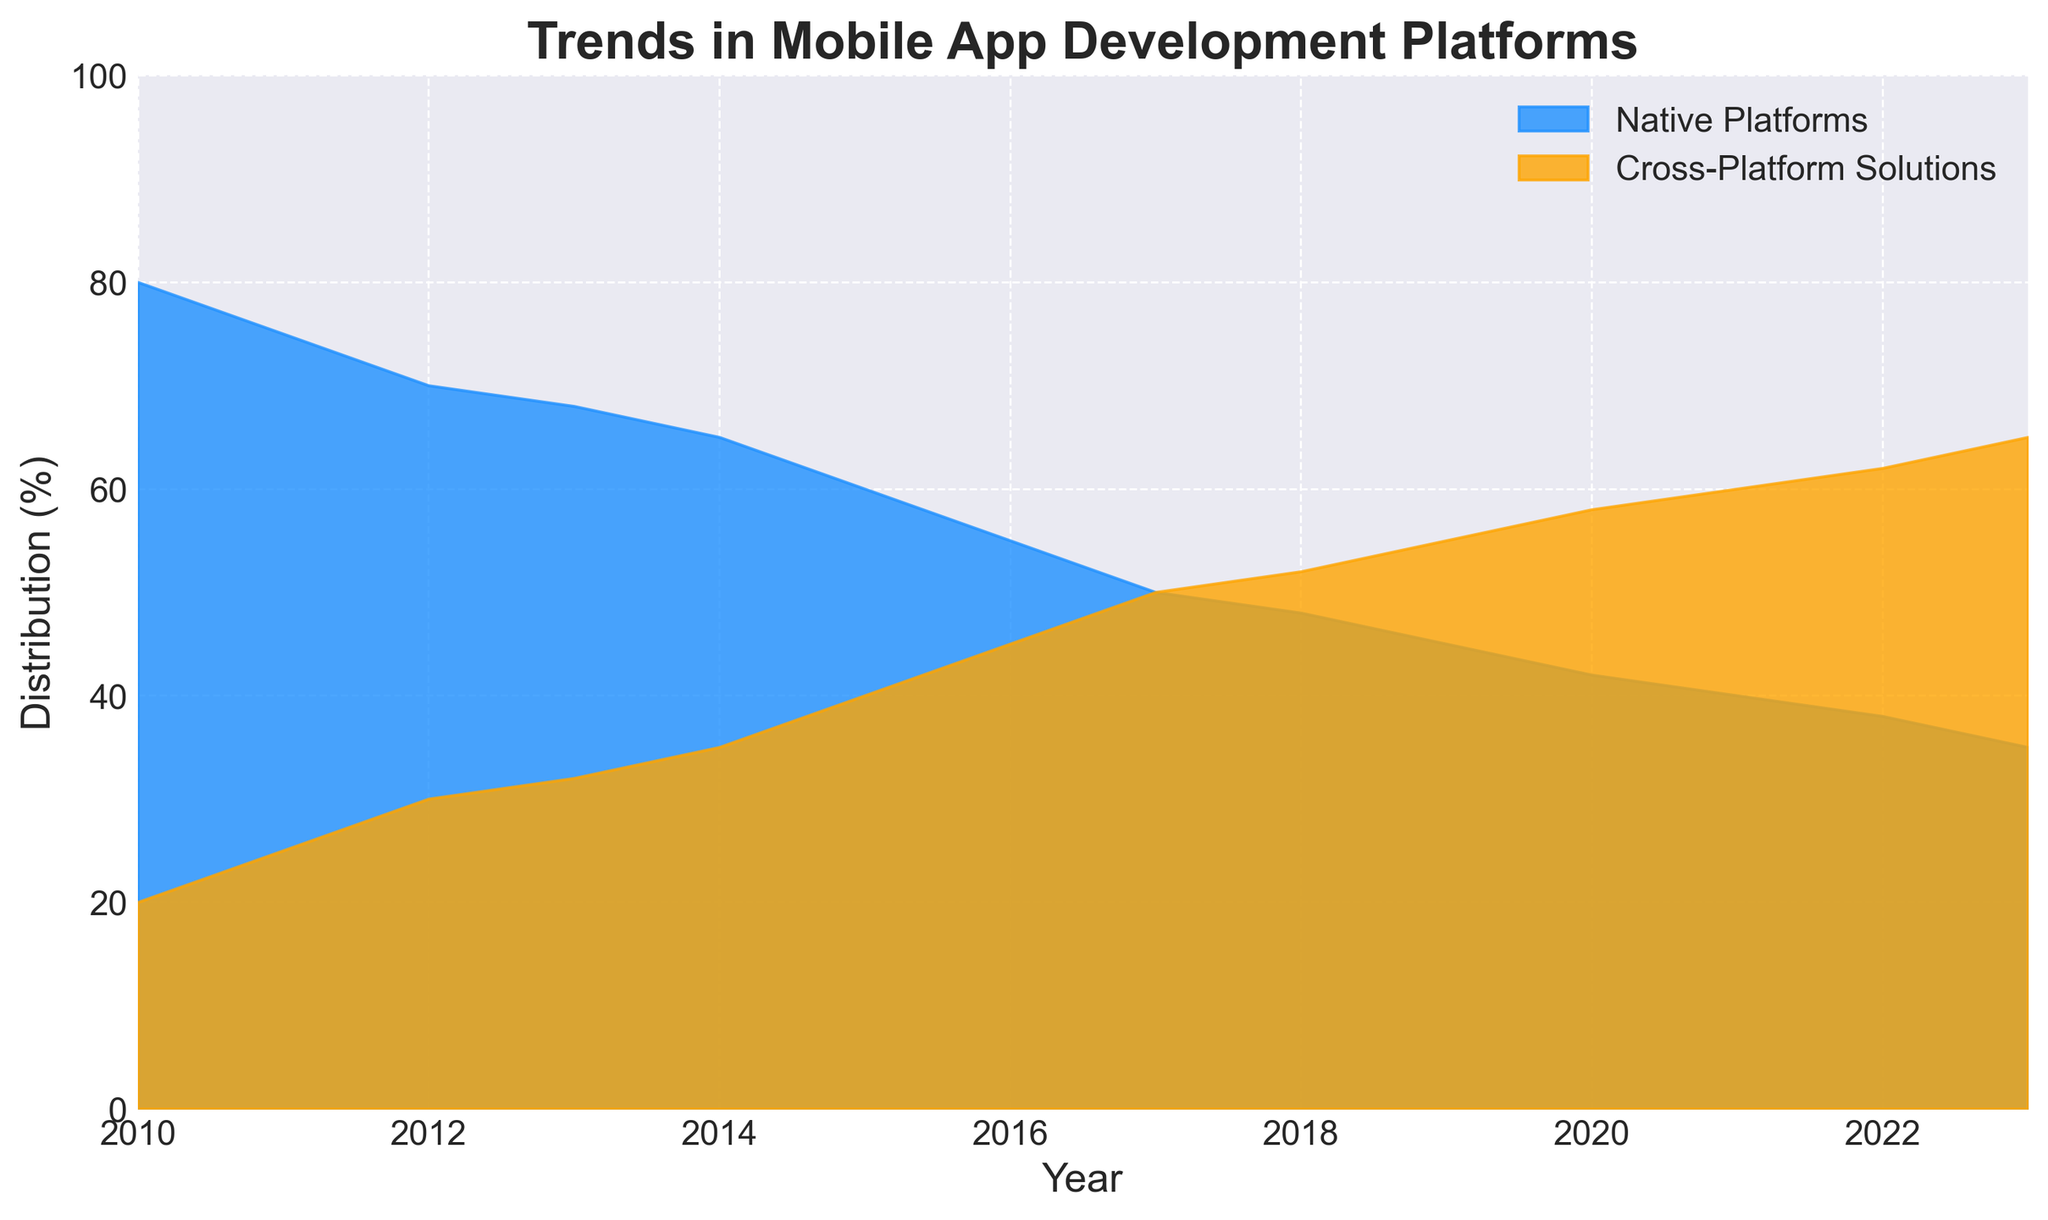What's the overall trend for Native Platforms from 2010 to 2023? Native Platforms show a consistent decline over the period from 2010 to 2023, dropping from 80% in 2010 to 35% in 2023.
Answer: Consistent decline What's the overall trend for Cross-Platform Solutions from 2010 to 2023? Cross-Platform Solutions show a consistent increase over the period from 2010 to 2023, rising from 20% in 2010 to 65% in 2023.
Answer: Consistent increase In which year did Cross-Platform Solutions first surpass Native Platforms? By examining the chart, we see that in 2018, Cross-Platform Solutions first surpass Native Platforms with a distribution of 52% vs. 48%.
Answer: 2018 What's the difference in percentage points between Native Platforms and Cross-Platform Solutions in 2023? In 2023, the percentage for Native Platforms is 35% and for Cross-Platform Solutions is 65%. The difference is 65% - 35% = 30 percentage points.
Answer: 30 percentage points What year did Native Platforms have exactly 50% of the distribution? By examining the figure, we can see that in 2017, Native Platforms had exactly 50% of the distribution.
Answer: 2017 Between which consecutive years did Native Platforms see the largest drop in percentage points? We need to check the drop between each pair of consecutive years from the chart. The largest drop is from 2015 to 2016, where it dropped from 60% to 55%, a 5 percentage point drop.
Answer: 2015 to 2016 Which year shows the smallest gap between Native Platforms and Cross-Platform Solutions? By examining the figure, the smallest gap between the two platforms is in 2017, where both platforms had an equal distribution of 50%.
Answer: 2017 How many years did it take for Cross-Platform Solutions to double their initial percentage from 2010? In 2010, Cross-Platform Solutions were at 20%. They reach 40% in 2015. Thus, it took 5 years (from 2010 to 2015) for Cross-Platform Solutions to double their percentage.
Answer: 5 years What's the average percentage for Cross-Platform Solutions over the entire period? Sum the percentages for Cross-Platform Solutions from 2010 to 2023 and divide by the number of years. (20 + 25 + 30 + 32 + 35 + 40 + 45 + 50 + 52 + 55 + 58 + 60 + 62 + 65) / 14 = 45.21%.
Answer: 45.21% How does the distribution in 2023 compare visually to the distribution in 2010? Visually, in 2010, Native Platforms fill a larger area of the chart (80%) compared to Cross-Platform Solutions (20%). In 2023, this is reversed, with Cross-Platform Solutions filling a larger area (65%) compared to Native Platforms (35%).
Answer: Reversed distribution 